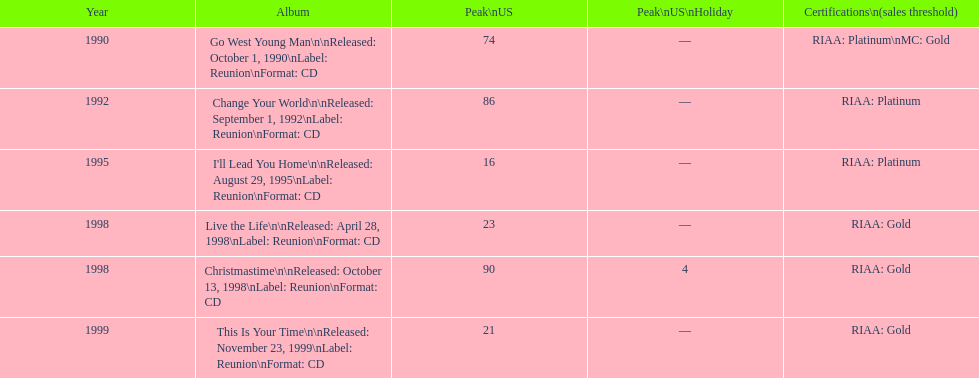What is the name of the first album by michael w. smith? Go West Young Man. 